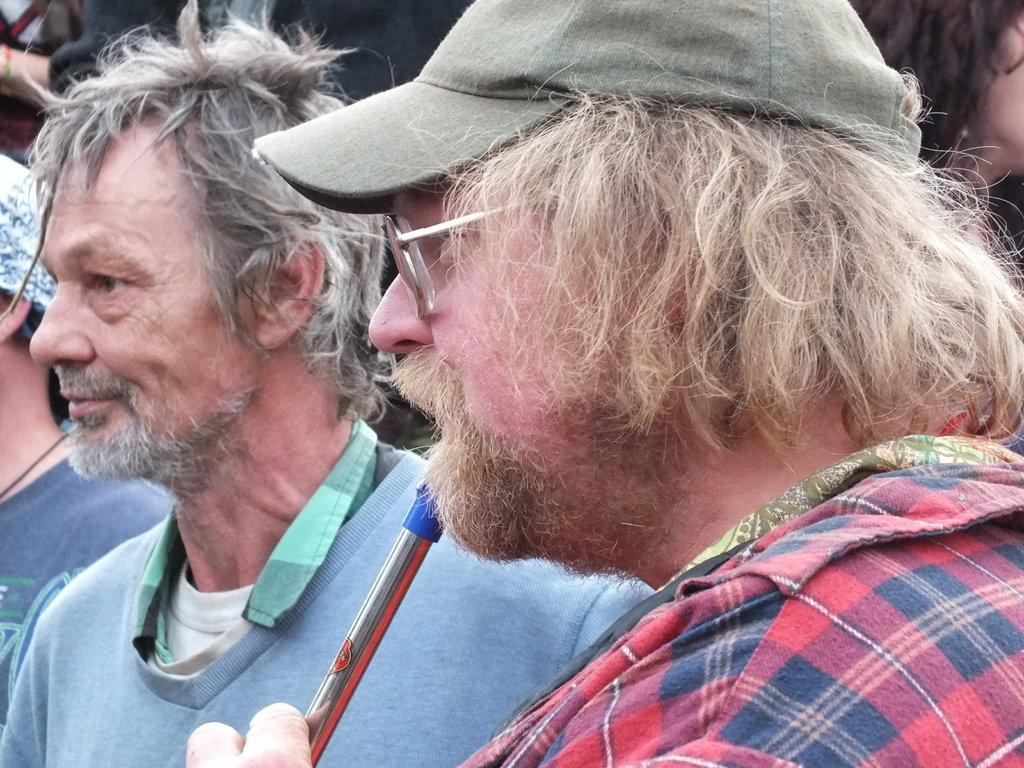How many men are visible in the image? There are two men in the image, one on the right side and one on the left side. Can you describe the positioning of the two men in the image? One man is on the right side and the other is on the left side. Are there any other people visible in the image besides the two men? Yes, there are other people behind the two men. What type of quilt is being used as a street cover in the image? There is no quilt or street cover present in the image. Can you describe the building in the background of the image? There is no building visible in the image; it only features the two men and other people behind them. 